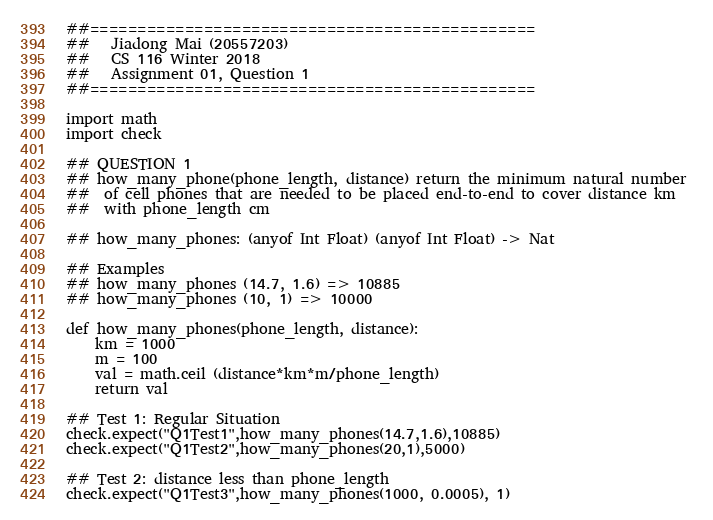Convert code to text. <code><loc_0><loc_0><loc_500><loc_500><_Python_>##===============================================
##   Jiadong Mai (20557203)
##   CS 116 Winter 2018
##   Assignment 01, Question 1
##===============================================

import math
import check

## QUESTION 1
## how_many_phone(phone_length, distance) return the minimum natural number 
##  of cell phones that are needed to be placed end-to-end to cover distance km
##  with phone_length cm

## how_many_phones: (anyof Int Float) (anyof Int Float) -> Nat

## Examples
## how_many_phones (14.7, 1.6) => 10885
## how_many_phones (10, 1) => 10000

def how_many_phones(phone_length, distance):
    km = 1000
    m = 100
    val = math.ceil (distance*km*m/phone_length)
    return val

## Test 1: Regular Situation
check.expect("Q1Test1",how_many_phones(14.7,1.6),10885)
check.expect("Q1Test2",how_many_phones(20,1),5000)

## Test 2: distance less than phone_length
check.expect("Q1Test3",how_many_phones(1000, 0.0005), 1)
</code> 